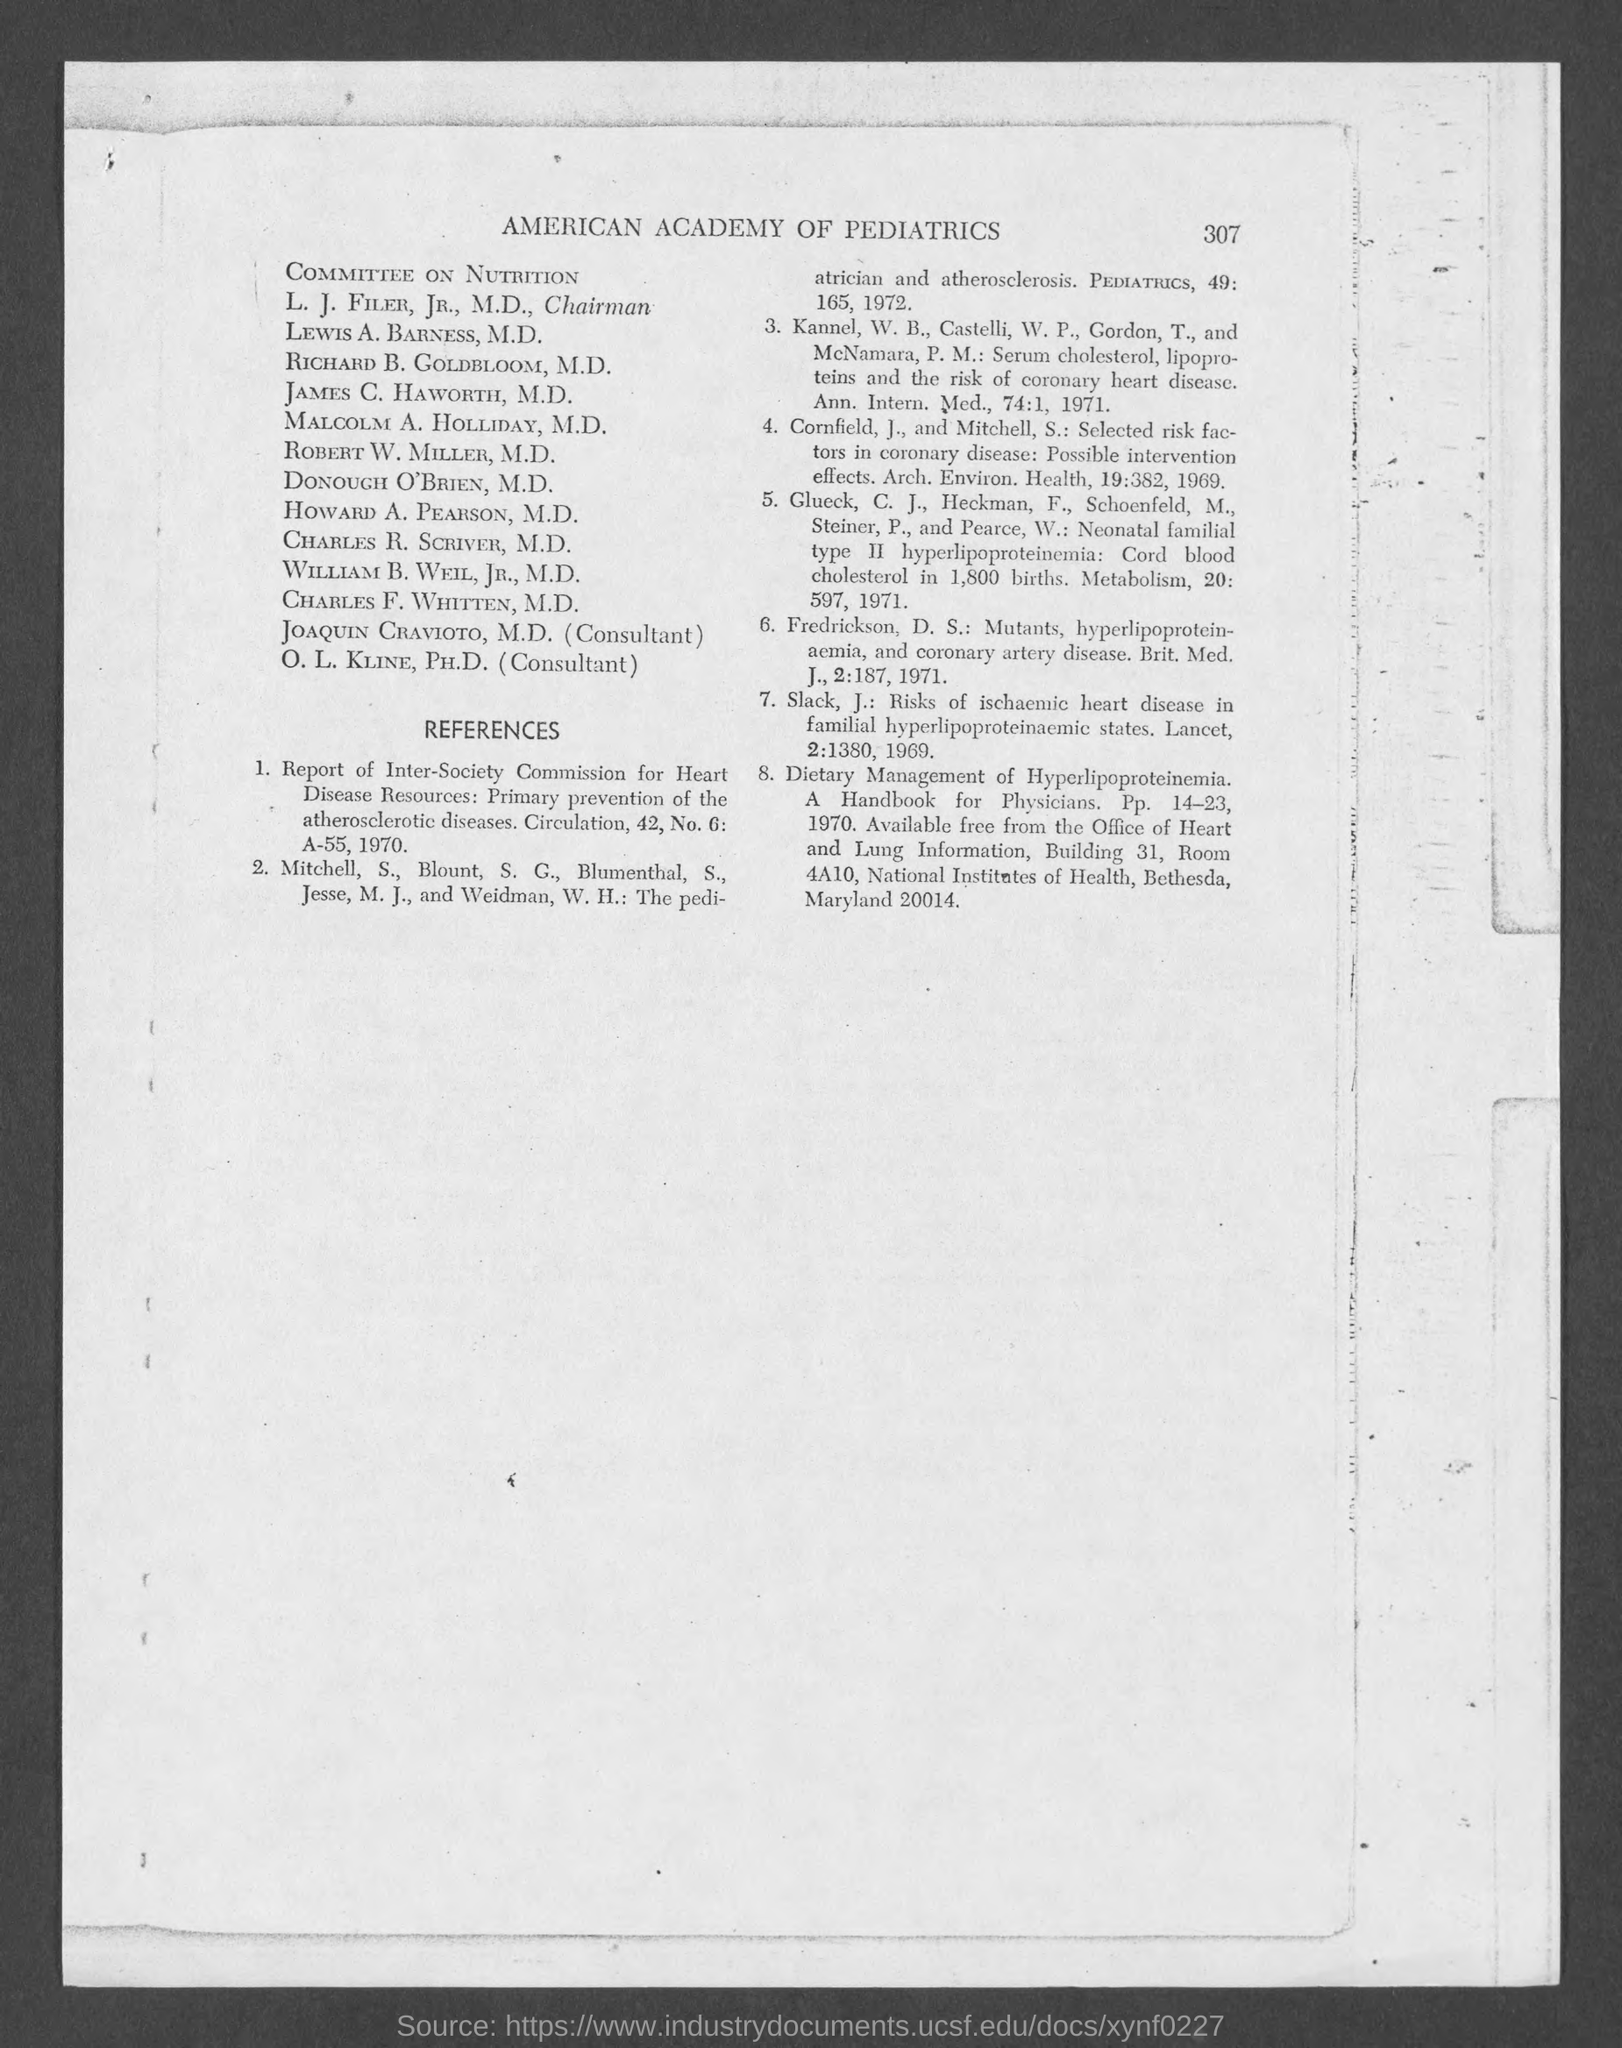Point out several critical features in this image. On the top of the page, the page number is 307. 